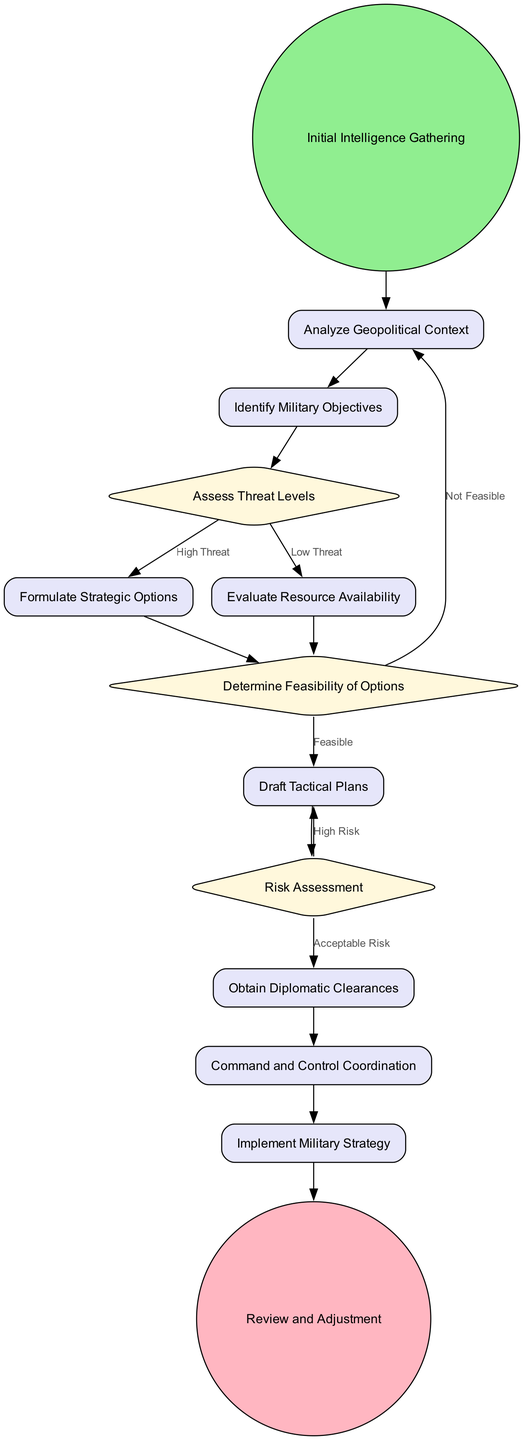What is the starting point of the workflow? The starting point of the workflow is represented by the "Initial Intelligence Gathering" node, which is the first element that initiates the process.
Answer: Initial Intelligence Gathering How many decision points are present in the diagram? The diagram contains three decision points: "Assess Threat Levels," "Determine Feasibility of Options," and "Risk Assessment." Upon counting these decision nodes, we arrive at the total.
Answer: 3 What happens after evaluating resource availability? After evaluating resource availability, the next step is to determine the feasibility of options, which is a decision point where the process may loop back or continue based on resource evaluation.
Answer: Determine Feasibility of Options If the threat level is low, what activity is performed next? If the threat level is low, the flow indicates that the next activity will be to evaluate resource availability, as per the flow direction from the decision node.
Answer: Evaluate Resource Availability What is the final node in the decision-making workflow? The final node in the decision-making workflow is labeled "Review and Adjustment," which signifies the end of the process after all activities have taken place.
Answer: Review and Adjustment What condition leads back to the initial intelligence gathering? The condition that leads back to the initial intelligence gathering occurs when the options are deemed "Not Feasible," prompting a revisit to the beginning of the analysis.
Answer: Not Feasible What is the activity following "Draft Tactical Plans"? The activity that follows "Draft Tactical Plans" is "Obtain Diplomatic Clearances," as indicated by the flow of the diagram connecting these two activities.
Answer: Obtain Diplomatic Clearances What are the conditions under the "Risk Assessment" decision node? The risk assessment decision node includes two conditions: "Acceptable Risk" leading to obtaining diplomatic clearances, and "High Risk" which loops back to drafting tactical plans again.
Answer: Acceptable Risk, High Risk 